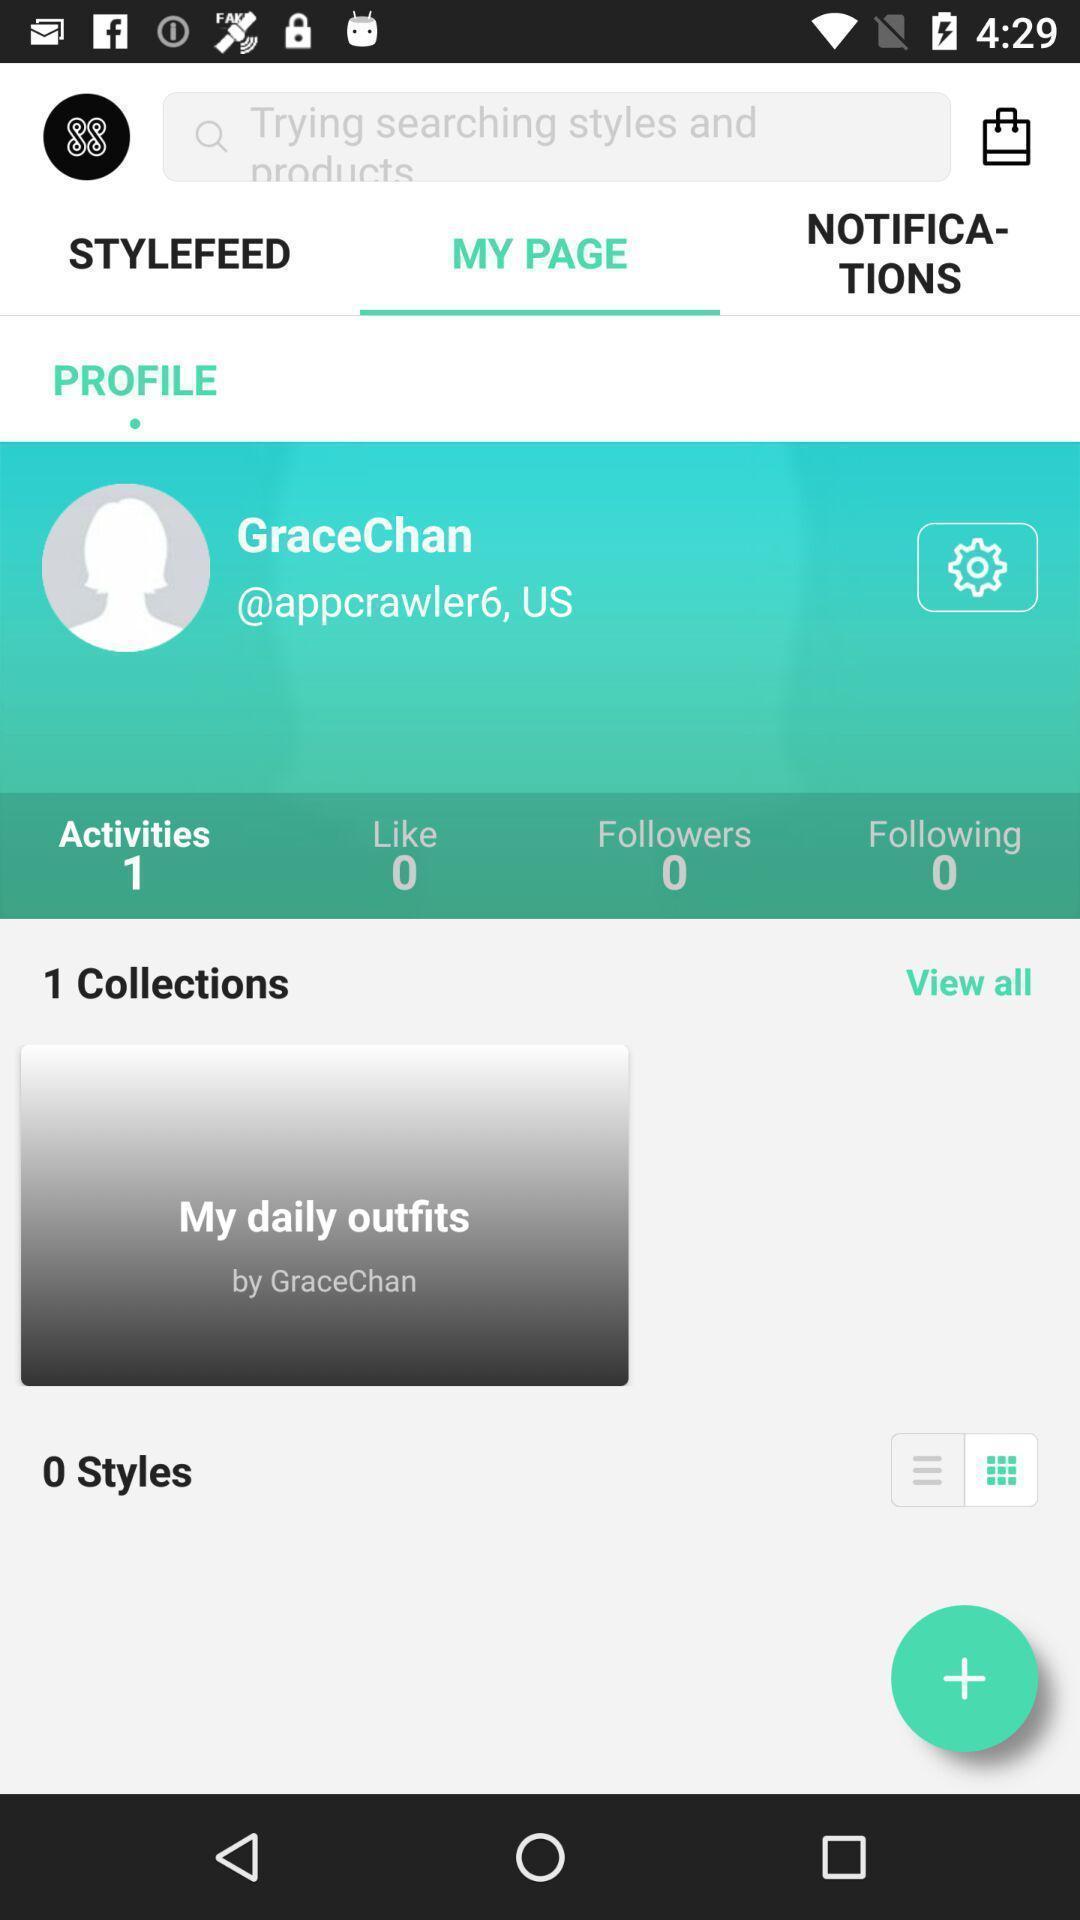Give me a summary of this screen capture. Search bar of a fashion application. 